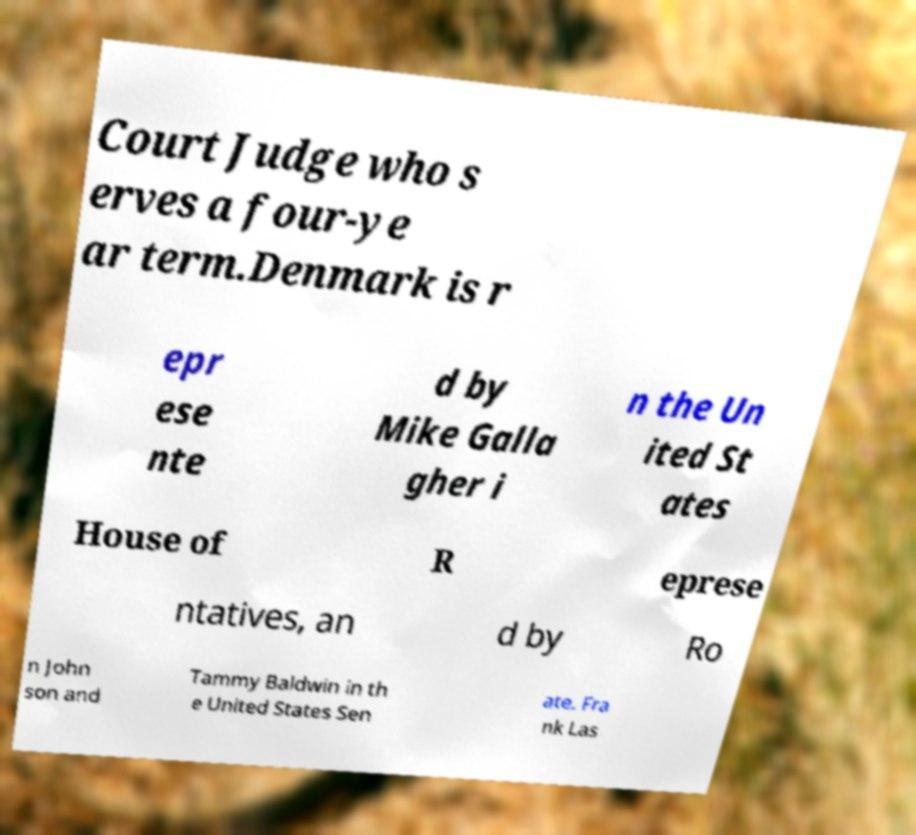Could you assist in decoding the text presented in this image and type it out clearly? Court Judge who s erves a four-ye ar term.Denmark is r epr ese nte d by Mike Galla gher i n the Un ited St ates House of R eprese ntatives, an d by Ro n John son and Tammy Baldwin in th e United States Sen ate. Fra nk Las 